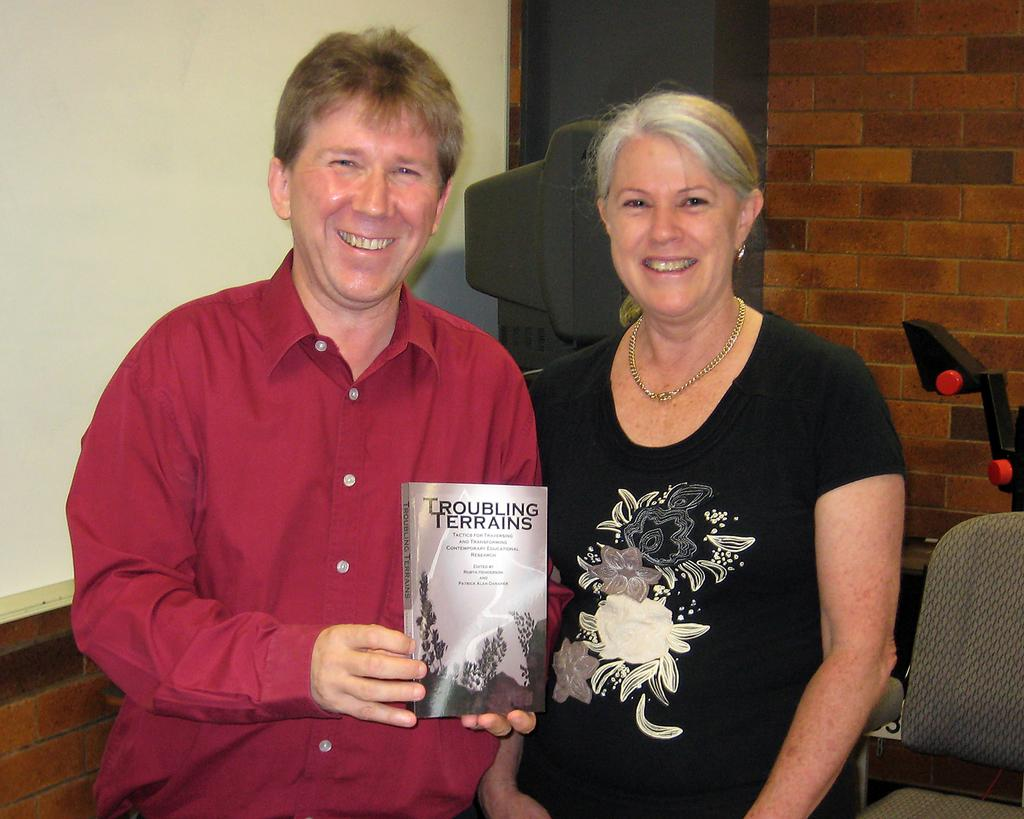<image>
Write a terse but informative summary of the picture. A man holds up a book called Troubling Terrains. 